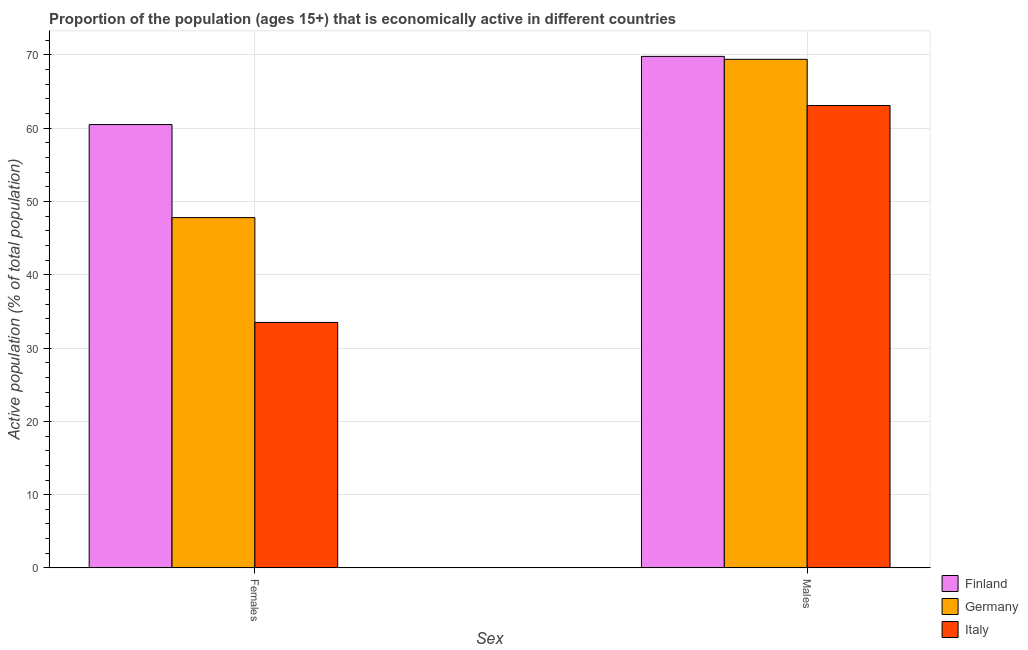How many different coloured bars are there?
Provide a succinct answer. 3. Are the number of bars per tick equal to the number of legend labels?
Provide a short and direct response. Yes. Are the number of bars on each tick of the X-axis equal?
Offer a terse response. Yes. How many bars are there on the 1st tick from the left?
Ensure brevity in your answer.  3. What is the label of the 2nd group of bars from the left?
Your answer should be very brief. Males. What is the percentage of economically active male population in Finland?
Keep it short and to the point. 69.8. Across all countries, what is the maximum percentage of economically active female population?
Provide a succinct answer. 60.5. Across all countries, what is the minimum percentage of economically active female population?
Ensure brevity in your answer.  33.5. In which country was the percentage of economically active female population maximum?
Provide a succinct answer. Finland. What is the total percentage of economically active male population in the graph?
Your answer should be compact. 202.3. What is the difference between the percentage of economically active male population in Italy and that in Germany?
Make the answer very short. -6.3. What is the difference between the percentage of economically active male population in Germany and the percentage of economically active female population in Italy?
Your answer should be very brief. 35.9. What is the average percentage of economically active male population per country?
Ensure brevity in your answer.  67.43. What is the difference between the percentage of economically active male population and percentage of economically active female population in Germany?
Your answer should be very brief. 21.6. In how many countries, is the percentage of economically active female population greater than 70 %?
Give a very brief answer. 0. What is the ratio of the percentage of economically active male population in Italy to that in Finland?
Keep it short and to the point. 0.9. In how many countries, is the percentage of economically active male population greater than the average percentage of economically active male population taken over all countries?
Give a very brief answer. 2. What does the 1st bar from the left in Males represents?
Keep it short and to the point. Finland. How many bars are there?
Provide a short and direct response. 6. Are all the bars in the graph horizontal?
Provide a short and direct response. No. How many countries are there in the graph?
Ensure brevity in your answer.  3. Does the graph contain any zero values?
Make the answer very short. No. Does the graph contain grids?
Your response must be concise. Yes. What is the title of the graph?
Make the answer very short. Proportion of the population (ages 15+) that is economically active in different countries. Does "Gambia, The" appear as one of the legend labels in the graph?
Offer a very short reply. No. What is the label or title of the X-axis?
Offer a terse response. Sex. What is the label or title of the Y-axis?
Make the answer very short. Active population (% of total population). What is the Active population (% of total population) of Finland in Females?
Provide a short and direct response. 60.5. What is the Active population (% of total population) of Germany in Females?
Keep it short and to the point. 47.8. What is the Active population (% of total population) in Italy in Females?
Your answer should be compact. 33.5. What is the Active population (% of total population) of Finland in Males?
Offer a very short reply. 69.8. What is the Active population (% of total population) of Germany in Males?
Offer a very short reply. 69.4. What is the Active population (% of total population) in Italy in Males?
Your answer should be very brief. 63.1. Across all Sex, what is the maximum Active population (% of total population) in Finland?
Give a very brief answer. 69.8. Across all Sex, what is the maximum Active population (% of total population) in Germany?
Offer a very short reply. 69.4. Across all Sex, what is the maximum Active population (% of total population) in Italy?
Make the answer very short. 63.1. Across all Sex, what is the minimum Active population (% of total population) in Finland?
Provide a short and direct response. 60.5. Across all Sex, what is the minimum Active population (% of total population) in Germany?
Give a very brief answer. 47.8. Across all Sex, what is the minimum Active population (% of total population) in Italy?
Give a very brief answer. 33.5. What is the total Active population (% of total population) of Finland in the graph?
Your answer should be compact. 130.3. What is the total Active population (% of total population) of Germany in the graph?
Make the answer very short. 117.2. What is the total Active population (% of total population) of Italy in the graph?
Make the answer very short. 96.6. What is the difference between the Active population (% of total population) of Germany in Females and that in Males?
Offer a very short reply. -21.6. What is the difference between the Active population (% of total population) of Italy in Females and that in Males?
Offer a terse response. -29.6. What is the difference between the Active population (% of total population) in Finland in Females and the Active population (% of total population) in Germany in Males?
Keep it short and to the point. -8.9. What is the difference between the Active population (% of total population) in Germany in Females and the Active population (% of total population) in Italy in Males?
Your answer should be compact. -15.3. What is the average Active population (% of total population) of Finland per Sex?
Provide a short and direct response. 65.15. What is the average Active population (% of total population) in Germany per Sex?
Give a very brief answer. 58.6. What is the average Active population (% of total population) of Italy per Sex?
Offer a terse response. 48.3. What is the difference between the Active population (% of total population) of Finland and Active population (% of total population) of Germany in Females?
Your answer should be very brief. 12.7. What is the difference between the Active population (% of total population) in Finland and Active population (% of total population) in Italy in Females?
Offer a very short reply. 27. What is the difference between the Active population (% of total population) of Finland and Active population (% of total population) of Italy in Males?
Your response must be concise. 6.7. What is the ratio of the Active population (% of total population) of Finland in Females to that in Males?
Give a very brief answer. 0.87. What is the ratio of the Active population (% of total population) of Germany in Females to that in Males?
Your answer should be very brief. 0.69. What is the ratio of the Active population (% of total population) of Italy in Females to that in Males?
Your answer should be compact. 0.53. What is the difference between the highest and the second highest Active population (% of total population) in Finland?
Provide a succinct answer. 9.3. What is the difference between the highest and the second highest Active population (% of total population) of Germany?
Provide a succinct answer. 21.6. What is the difference between the highest and the second highest Active population (% of total population) in Italy?
Make the answer very short. 29.6. What is the difference between the highest and the lowest Active population (% of total population) in Finland?
Offer a terse response. 9.3. What is the difference between the highest and the lowest Active population (% of total population) of Germany?
Your answer should be very brief. 21.6. What is the difference between the highest and the lowest Active population (% of total population) in Italy?
Offer a very short reply. 29.6. 